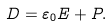Convert formula to latex. <formula><loc_0><loc_0><loc_500><loc_500>D = \varepsilon _ { 0 } E + P .</formula> 